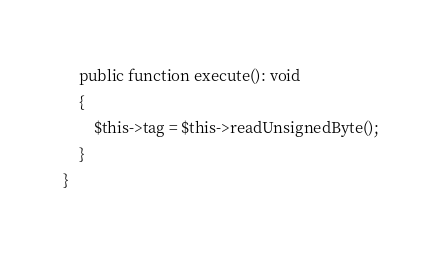Convert code to text. <code><loc_0><loc_0><loc_500><loc_500><_PHP_>
    public function execute(): void
    {
        $this->tag = $this->readUnsignedByte();
    }
}
</code> 